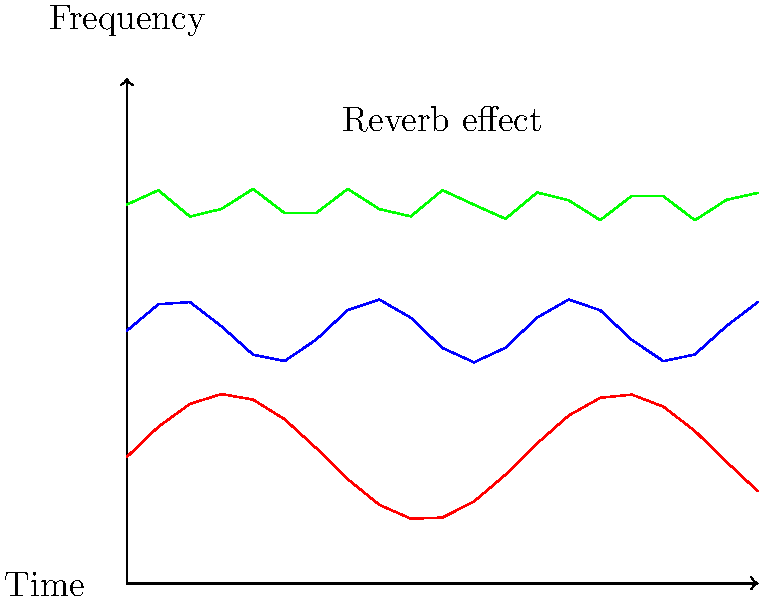Analyze the spectrogram above, which represents a portion of a film soundtrack. What specific audio effect is most likely being depicted by the multiple, parallel wavy lines at different frequencies? To identify the audio effect represented in the spectrogram, let's analyze its key features:

1. Multiple parallel lines: The spectrogram shows three distinct wavy lines at different frequency levels.

2. Frequency distribution: The lines are evenly spaced along the frequency axis, suggesting harmonically related components.

3. Temporal characteristics: All lines exhibit a similar wavy pattern over time, indicating a consistent modulation effect.

4. Decay pattern: The amplitude of the waves decreases as frequency increases (red line has the highest amplitude, green line the lowest), suggesting a natural decay of higher harmonics.

5. Persistence: The effect continues throughout the time frame, implying a sustained sound modification.

These characteristics are typical of a reverb effect:

- Multiple lines represent the original sound and its reflections.
- The wavy pattern indicates the complex interactions of sound waves in a space.
- The decay of higher frequencies is consistent with how reverb behaves in natural environments.
- The persistent nature of the effect matches the continuous nature of reverberations.

The label "Reverb effect" in the spectrogram confirms this analysis.
Answer: Reverb 